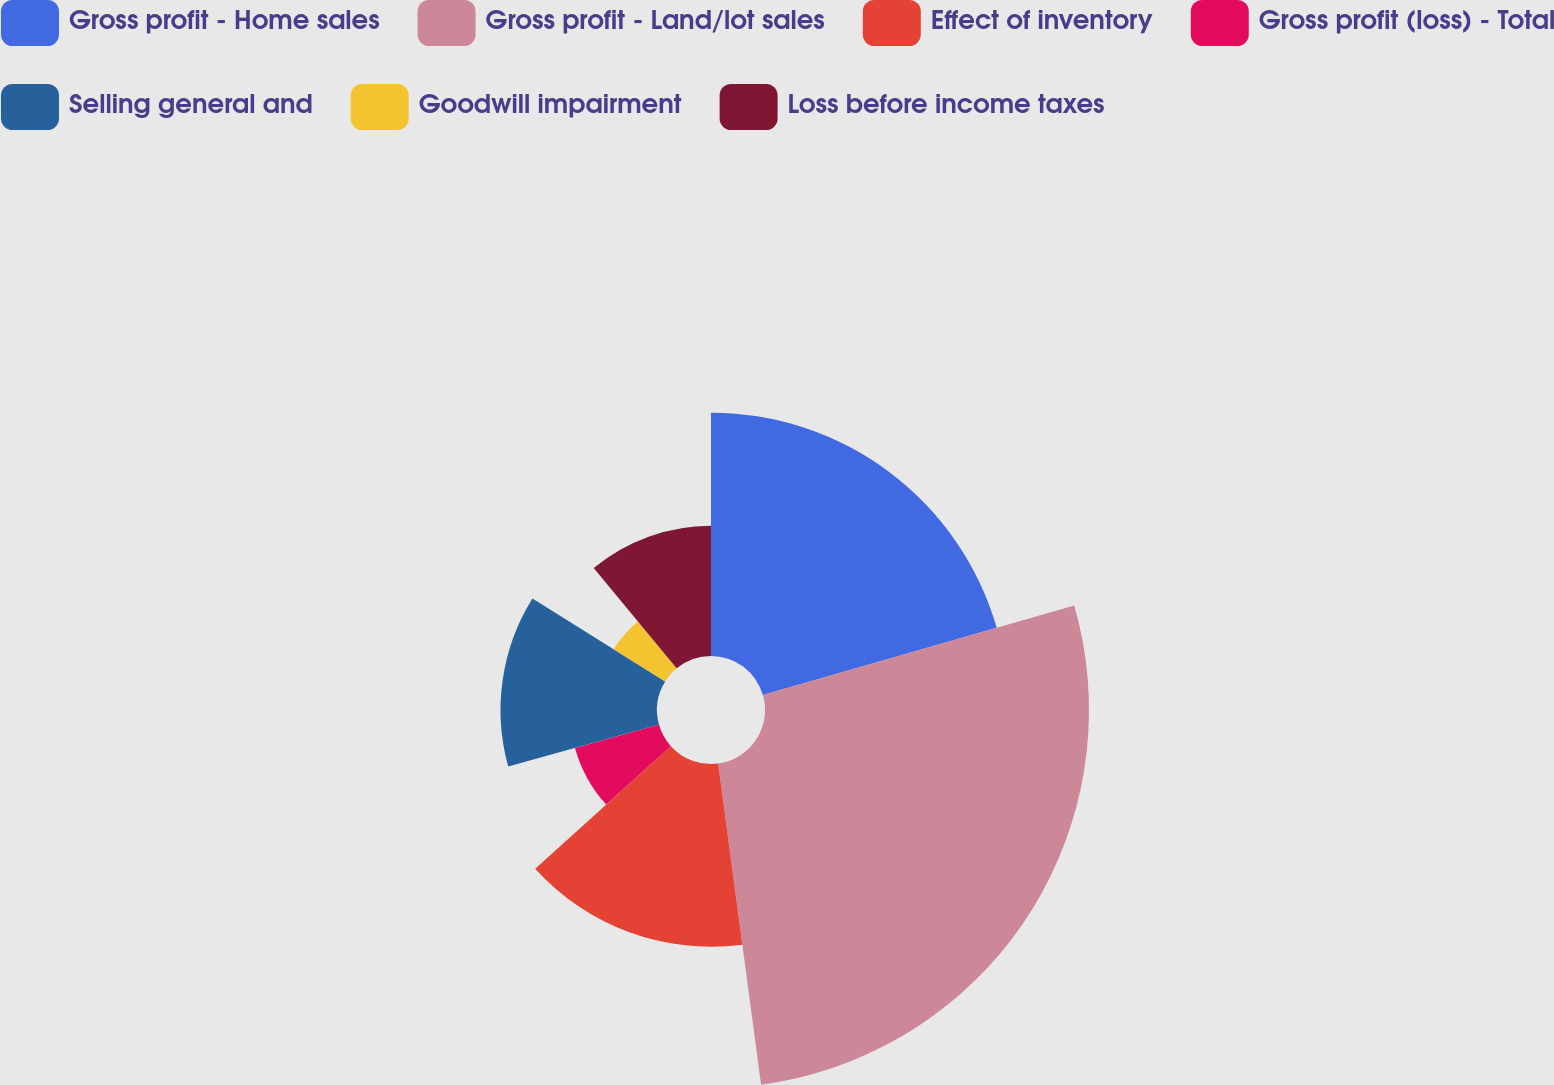<chart> <loc_0><loc_0><loc_500><loc_500><pie_chart><fcel>Gross profit - Home sales<fcel>Gross profit - Land/lot sales<fcel>Effect of inventory<fcel>Gross profit (loss) - Total<fcel>Selling general and<fcel>Goodwill impairment<fcel>Loss before income taxes<nl><fcel>20.54%<fcel>27.35%<fcel>15.43%<fcel>7.36%<fcel>13.21%<fcel>5.13%<fcel>10.99%<nl></chart> 